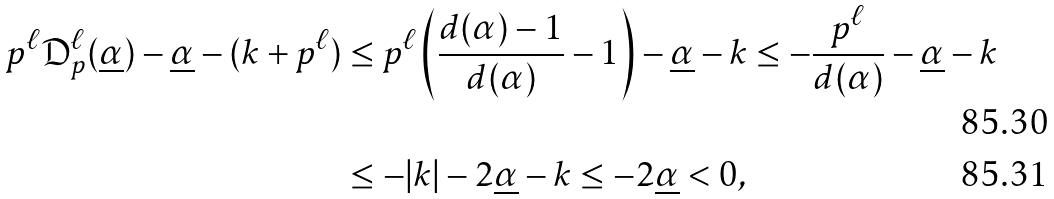Convert formula to latex. <formula><loc_0><loc_0><loc_500><loc_500>p ^ { \ell } \mathfrak { D } _ { p } ^ { \ell } ( \underline { \alpha } ) - \underline { \alpha } - ( k + p ^ { \ell } ) & \leq p ^ { \ell } \left ( \frac { d ( \alpha ) - 1 } { d ( \alpha ) } - 1 \right ) - \underline { \alpha } - k \leq - \frac { p ^ { \ell } } { d ( \alpha ) } - \underline { \alpha } - k \\ & \leq - | k | - 2 \underline { \alpha } - k \leq - 2 \underline { \alpha } < 0 ,</formula> 